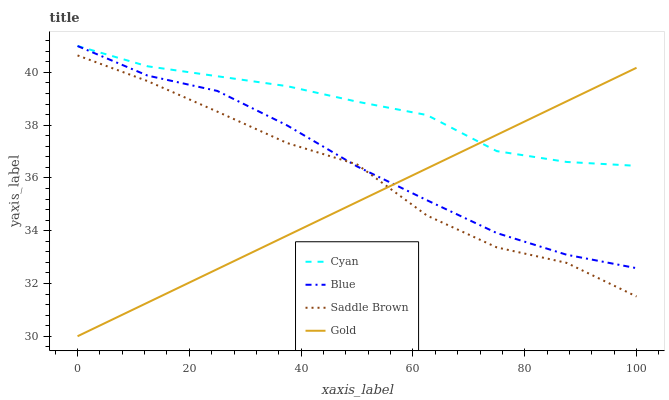Does Gold have the minimum area under the curve?
Answer yes or no. Yes. Does Cyan have the maximum area under the curve?
Answer yes or no. Yes. Does Saddle Brown have the minimum area under the curve?
Answer yes or no. No. Does Saddle Brown have the maximum area under the curve?
Answer yes or no. No. Is Gold the smoothest?
Answer yes or no. Yes. Is Saddle Brown the roughest?
Answer yes or no. Yes. Is Cyan the smoothest?
Answer yes or no. No. Is Cyan the roughest?
Answer yes or no. No. Does Saddle Brown have the lowest value?
Answer yes or no. No. Does Saddle Brown have the highest value?
Answer yes or no. No. Is Saddle Brown less than Cyan?
Answer yes or no. Yes. Is Cyan greater than Saddle Brown?
Answer yes or no. Yes. Does Saddle Brown intersect Cyan?
Answer yes or no. No. 